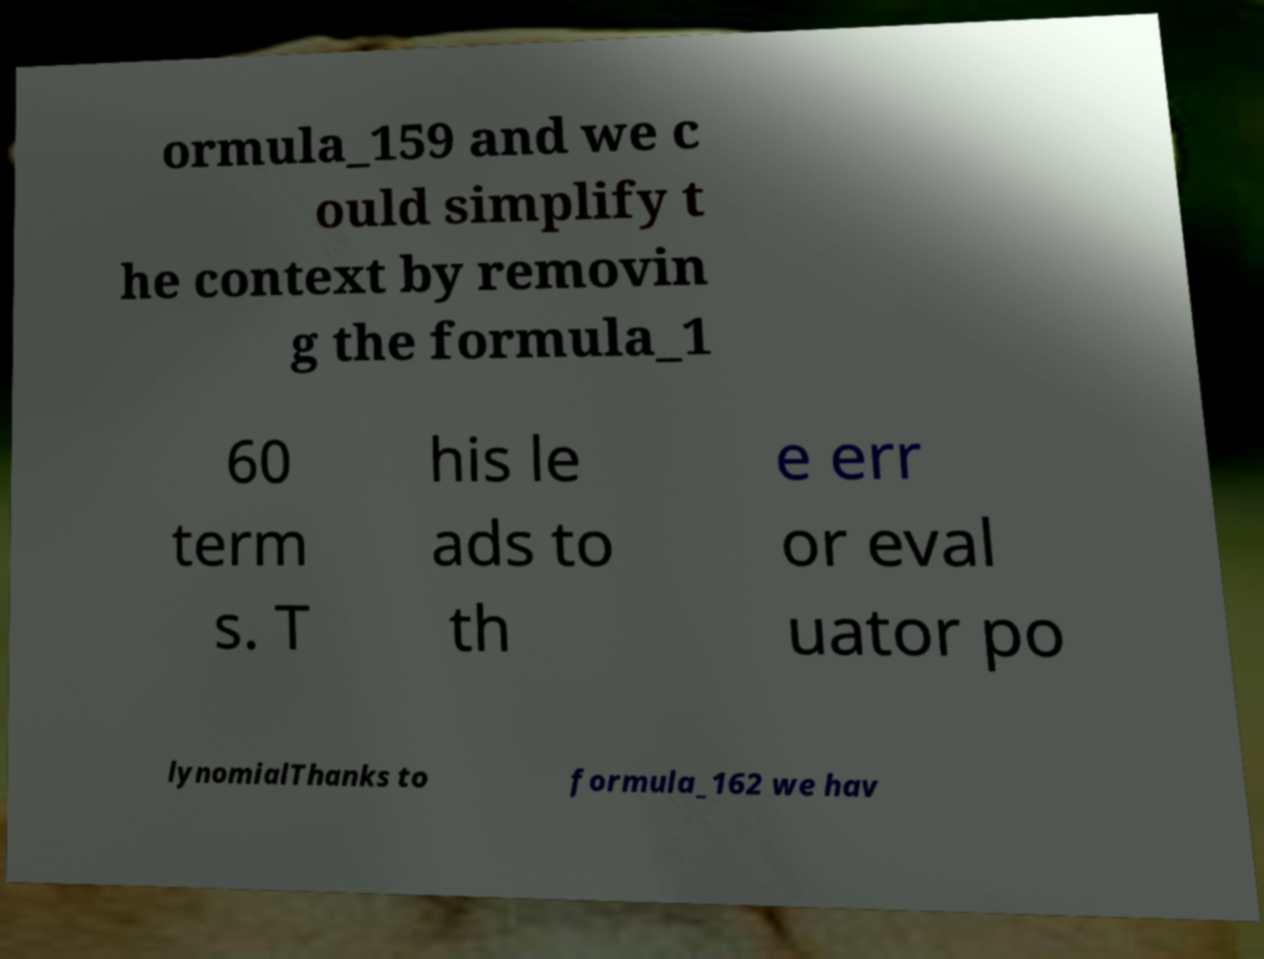Please identify and transcribe the text found in this image. ormula_159 and we c ould simplify t he context by removin g the formula_1 60 term s. T his le ads to th e err or eval uator po lynomialThanks to formula_162 we hav 